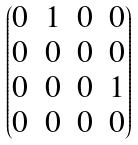Convert formula to latex. <formula><loc_0><loc_0><loc_500><loc_500>\begin{pmatrix} 0 & 1 & 0 & 0 \\ 0 & 0 & 0 & 0 \\ 0 & 0 & 0 & 1 \\ 0 & 0 & 0 & 0 \end{pmatrix}</formula> 